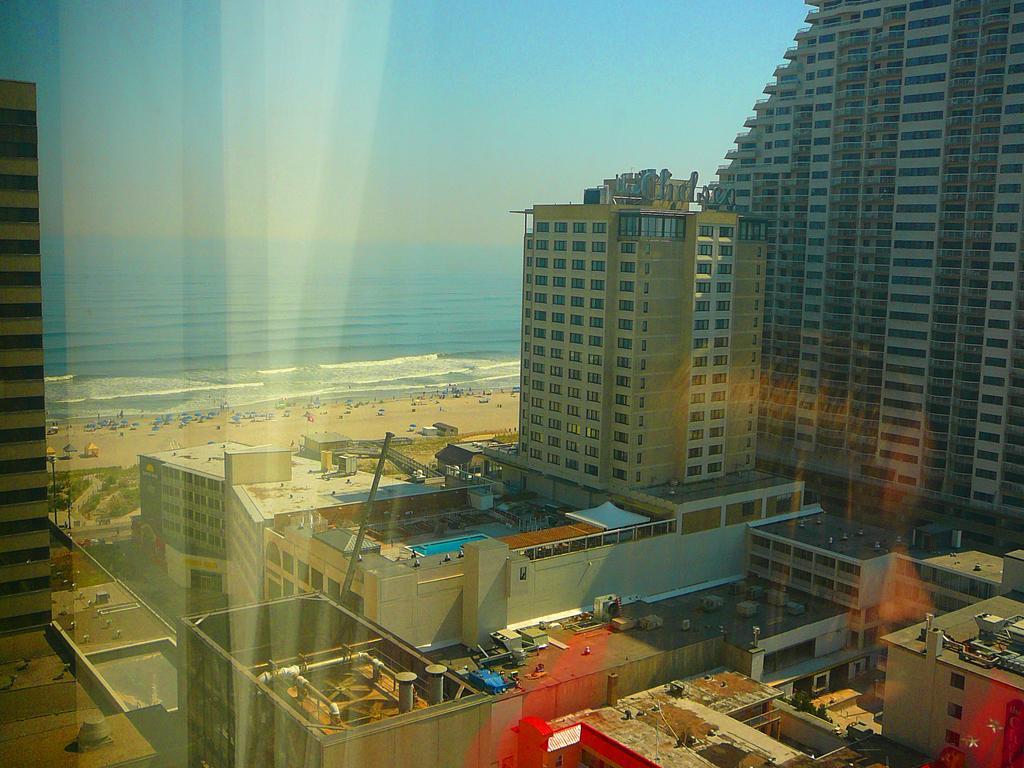How would you summarize this image in a sentence or two? In this image we can see a group of buildings with windows. We can also see some trees, a street pole and a group of people on a seashore. On the backside we can see a large water body and the sky. 